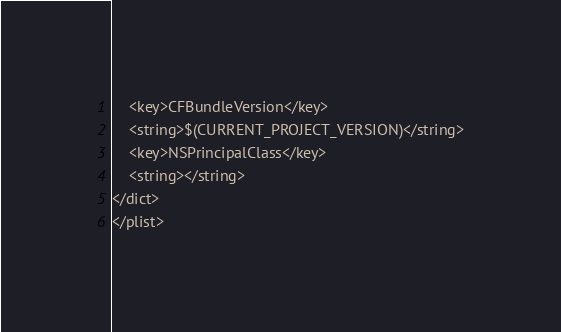<code> <loc_0><loc_0><loc_500><loc_500><_XML_>	<key>CFBundleVersion</key>
	<string>$(CURRENT_PROJECT_VERSION)</string>
	<key>NSPrincipalClass</key>
	<string></string>
</dict>
</plist>
</code> 